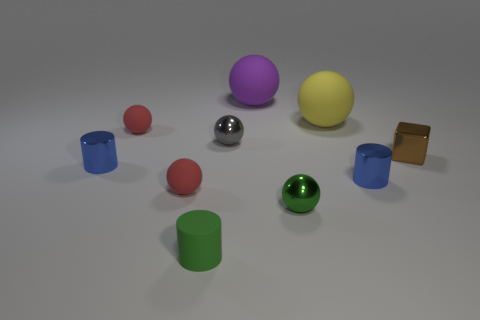Is the tiny cylinder that is right of the green matte object made of the same material as the large yellow object?
Your response must be concise. No. Is the number of tiny green metallic objects behind the purple matte ball the same as the number of small things behind the brown shiny thing?
Your answer should be compact. No. There is a red thing that is in front of the tiny metallic block; how big is it?
Your answer should be very brief. Small. Is there a small purple sphere made of the same material as the big yellow object?
Give a very brief answer. No. Is the color of the rubber ball that is in front of the small brown metal thing the same as the small rubber cylinder?
Give a very brief answer. No. Are there the same number of large yellow objects in front of the green cylinder and big brown balls?
Offer a terse response. Yes. Is there a metal thing that has the same color as the matte cylinder?
Your answer should be very brief. Yes. Is the size of the gray ball the same as the brown object?
Make the answer very short. Yes. How big is the red object that is in front of the small metallic cylinder to the left of the small gray sphere?
Provide a short and direct response. Small. There is a rubber sphere that is on the left side of the tiny gray shiny thing and behind the gray shiny object; what size is it?
Offer a very short reply. Small. 